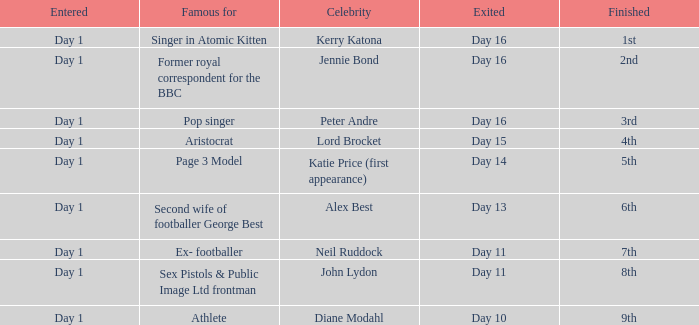Could you parse the entire table? {'header': ['Entered', 'Famous for', 'Celebrity', 'Exited', 'Finished'], 'rows': [['Day 1', 'Singer in Atomic Kitten', 'Kerry Katona', 'Day 16', '1st'], ['Day 1', 'Former royal correspondent for the BBC', 'Jennie Bond', 'Day 16', '2nd'], ['Day 1', 'Pop singer', 'Peter Andre', 'Day 16', '3rd'], ['Day 1', 'Aristocrat', 'Lord Brocket', 'Day 15', '4th'], ['Day 1', 'Page 3 Model', 'Katie Price (first appearance)', 'Day 14', '5th'], ['Day 1', 'Second wife of footballer George Best', 'Alex Best', 'Day 13', '6th'], ['Day 1', 'Ex- footballer', 'Neil Ruddock', 'Day 11', '7th'], ['Day 1', 'Sex Pistols & Public Image Ltd frontman', 'John Lydon', 'Day 11', '8th'], ['Day 1', 'Athlete', 'Diane Modahl', 'Day 10', '9th']]} Name the finished for exited of day 13 6th. 